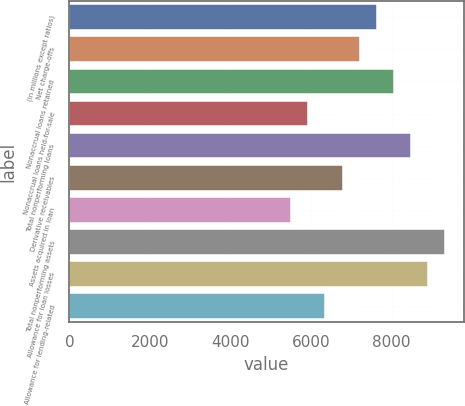<chart> <loc_0><loc_0><loc_500><loc_500><bar_chart><fcel>(in millions except ratios)<fcel>Net charge-offs<fcel>Nonaccrual loans retained<fcel>Nonaccrual loans held-for-sale<fcel>Total nonperforming loans<fcel>Derivative receivables<fcel>Assets acquired in loan<fcel>Total nonperforming assets<fcel>Allowance for loan losses<fcel>Allowance for lending-related<nl><fcel>7631.44<fcel>7207.64<fcel>8055.24<fcel>5936.24<fcel>8479.04<fcel>6783.84<fcel>5512.44<fcel>9326.64<fcel>8902.84<fcel>6360.04<nl></chart> 